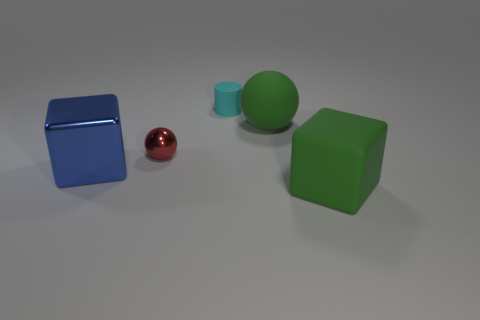Add 2 small cyan matte objects. How many objects exist? 7 Subtract all cylinders. How many objects are left? 4 Add 2 tiny cylinders. How many tiny cylinders exist? 3 Subtract 0 yellow balls. How many objects are left? 5 Subtract all brown metallic blocks. Subtract all blue metal cubes. How many objects are left? 4 Add 5 cylinders. How many cylinders are left? 6 